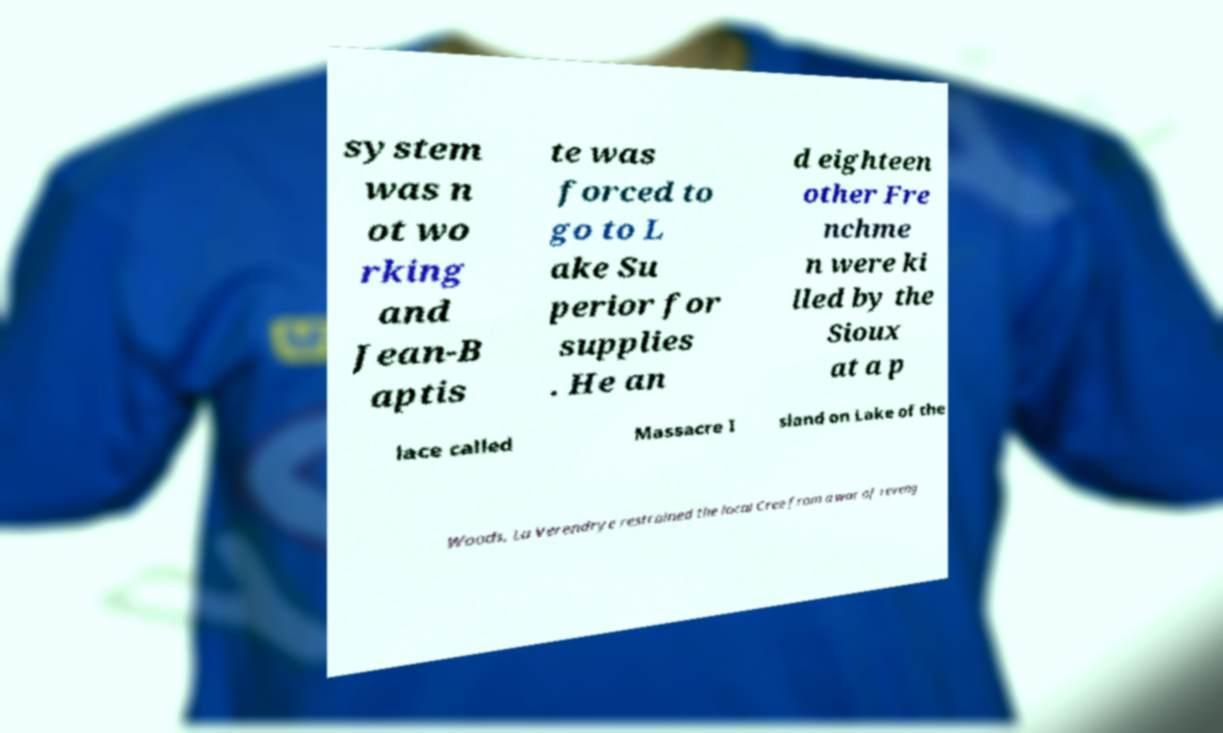Please read and relay the text visible in this image. What does it say? system was n ot wo rking and Jean-B aptis te was forced to go to L ake Su perior for supplies . He an d eighteen other Fre nchme n were ki lled by the Sioux at a p lace called Massacre I sland on Lake of the Woods. La Verendrye restrained the local Cree from a war of reveng 